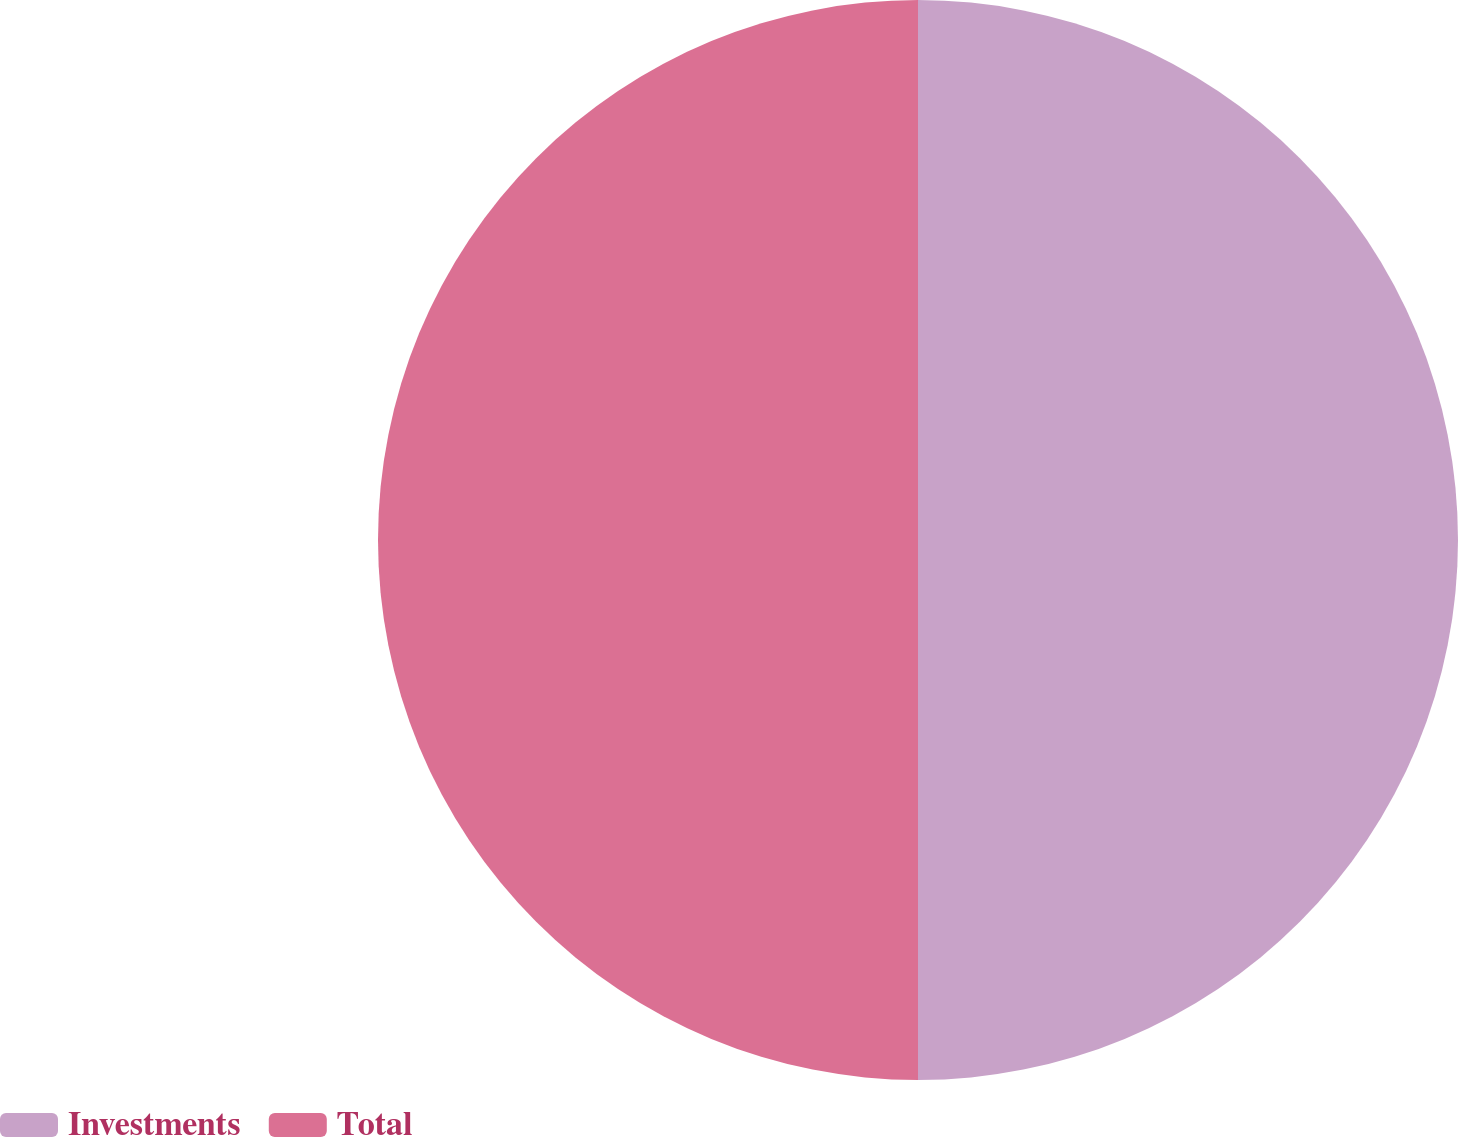Convert chart. <chart><loc_0><loc_0><loc_500><loc_500><pie_chart><fcel>Investments<fcel>Total<nl><fcel>50.0%<fcel>50.0%<nl></chart> 